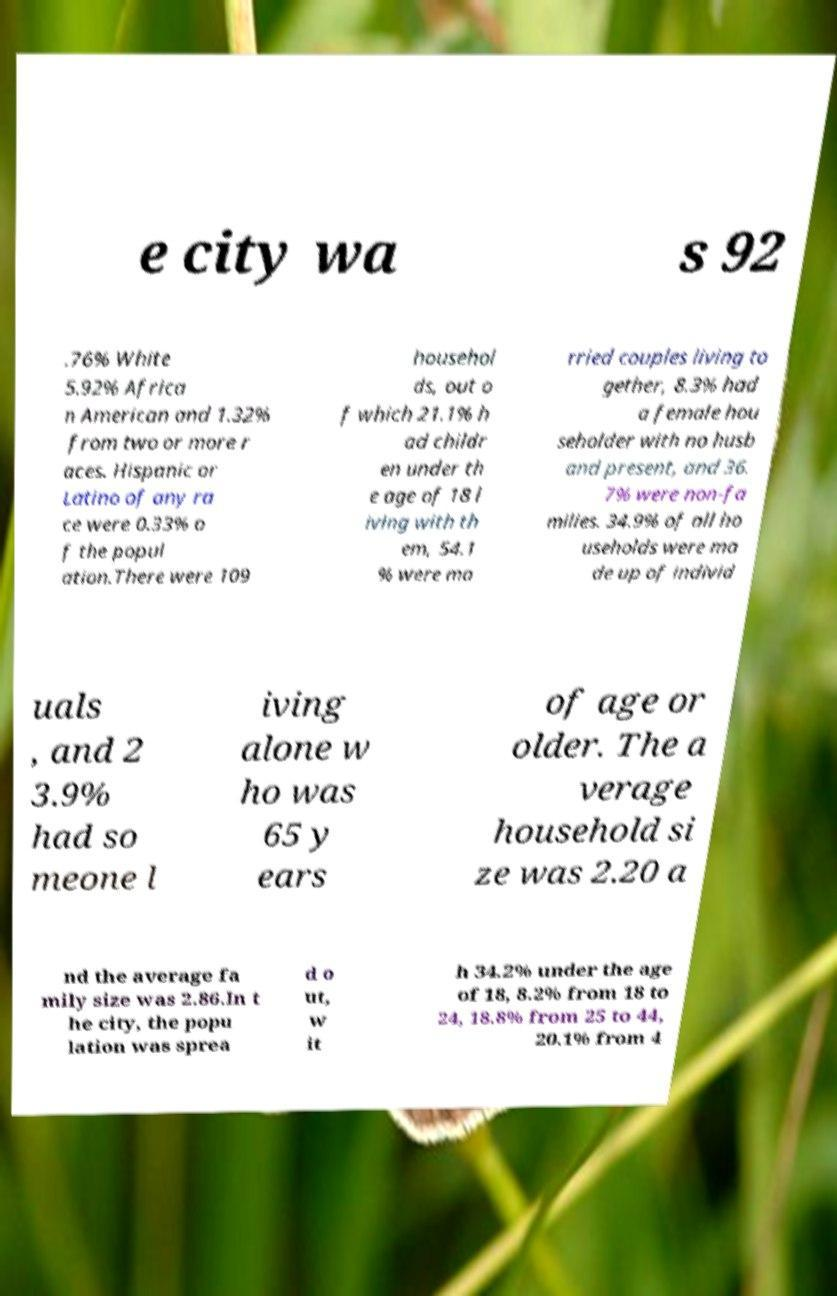Can you read and provide the text displayed in the image?This photo seems to have some interesting text. Can you extract and type it out for me? e city wa s 92 .76% White 5.92% Africa n American and 1.32% from two or more r aces. Hispanic or Latino of any ra ce were 0.33% o f the popul ation.There were 109 househol ds, out o f which 21.1% h ad childr en under th e age of 18 l iving with th em, 54.1 % were ma rried couples living to gether, 8.3% had a female hou seholder with no husb and present, and 36. 7% were non-fa milies. 34.9% of all ho useholds were ma de up of individ uals , and 2 3.9% had so meone l iving alone w ho was 65 y ears of age or older. The a verage household si ze was 2.20 a nd the average fa mily size was 2.86.In t he city, the popu lation was sprea d o ut, w it h 34.2% under the age of 18, 8.2% from 18 to 24, 18.8% from 25 to 44, 20.1% from 4 